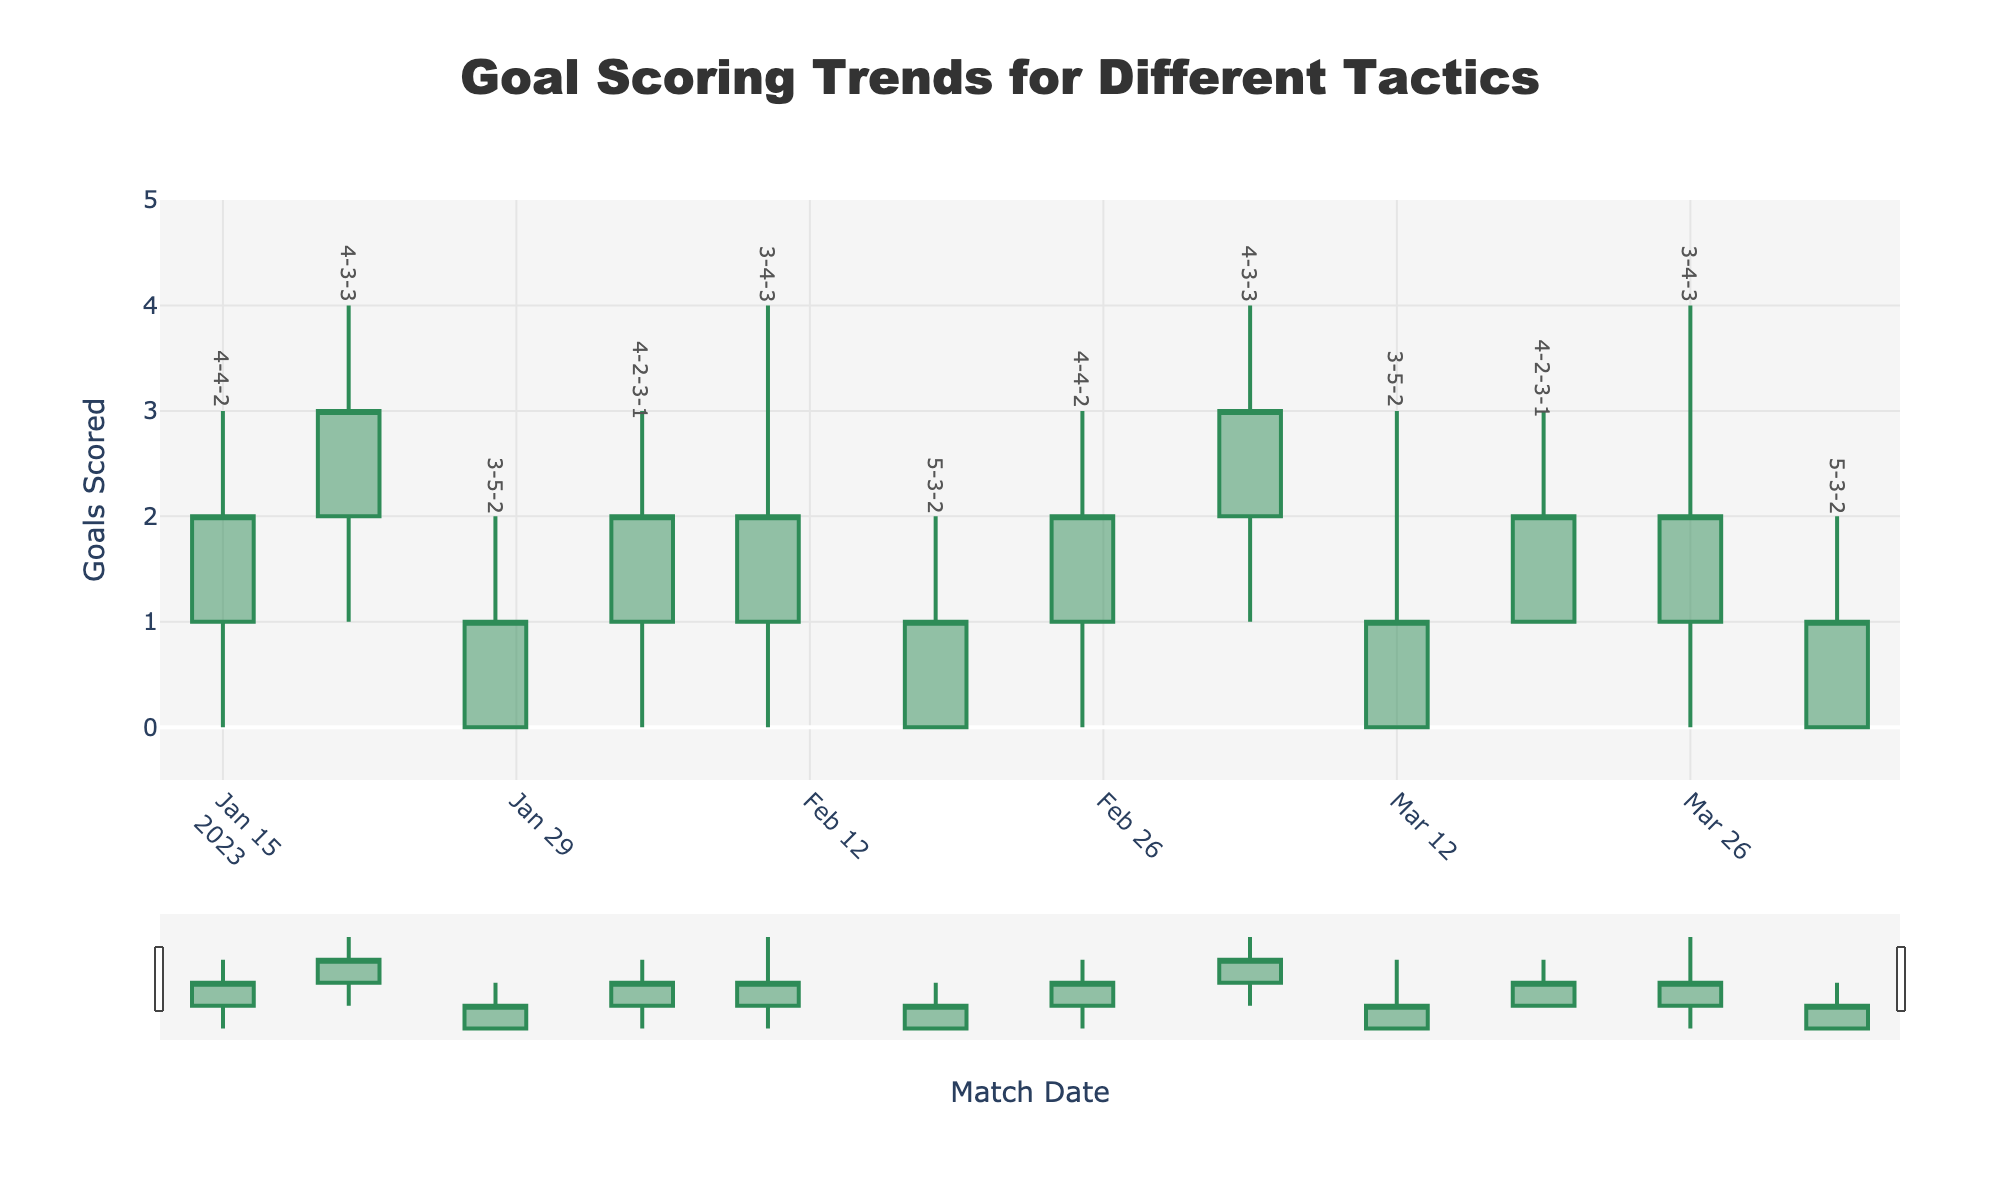What is the title of the figure? The title of the figure is located at the top center and reads "Goal Scoring Trends for Different Tactics."
Answer: Goal Scoring Trends for Different Tactics What tactic is associated with the highest goals scored in February 2023? By checking the February data points, the highest goal scoring tactic in February is where the candlestick reaches the highest value. On February 10th, 2023, the '3-4-3' tactic reached 4 goals.
Answer: 3-4-3 How many times did the '4-4-2' tactic get used according to the chart? By counting the visible tactic labels, the '4-4-2' tactic appears twice on January 15th, 2023, and February 25th, 2023.
Answer: 2 Which tactic had the highest average number of goals scored (High value) across matches? Calculate the average high values for each tactic. '4-4-2': (3 + 3) / 2 = 3, '4-3-3': (4 + 4) / 2 = 4, '3-5-2': (2 + 3) / 2 = 2.5, '4-2-3-1': (3 + 3) / 2 = 3, '3-4-3': (4 + 4) / 2 = 4, '5-3-2': (2 + 2) / 2 = 2. '4-3-3' and '3-4-3' both have average high values of 4.
Answer: 4-3-3, 3-4-3 What is the range of the y-axis? The y-axis range is specified in the layout settings, ranging from -0.5 to 5, as seen on the left side of the plot.
Answer: -0.5 to 5 On which date did the '5-3-2' tactic score its highest number of goals, and what was that number? The '5-3-2' tactic appears on February 18th, 2023, and April 2nd, 2023. On both dates, the high value is 2.
Answer: February 18th, April 2nd, 2 goals Which tactic had the lowest scoring match (Low value) and when did it occur? Checking the low values, the lowest is 0. This occurs multiple times, including '4-4-2' on several dates, but the first one appears on January 15th, 2023.
Answer: 4-4-2, January 15th, 2023 Compare the highest and lowest goals scored using the '4-2-3-1' tactic. What is the difference? '4-2-3-1' tactic has a high value of 3 and a low value of 0 on both its appearances. The difference is 3.
Answer: 3 Which month had the most varied goal-scoring trends in terms of the range (difference between High and Low) shown in the plot? Calculate the range for each month. January (4-4-2: 3-0=3, 4-3-3: 4-1=3), February (4-2-3-1: 3-0=3, 3-4-3: 4-0=4, 5-3-2: 2-0=2), and March (4-2-3-1: 3-1=2, 4-3-3: 4-1=3, 3-5-2: 3-0=3). February has the highest individual variation of 4 with '3-4-3'.
Answer: February 